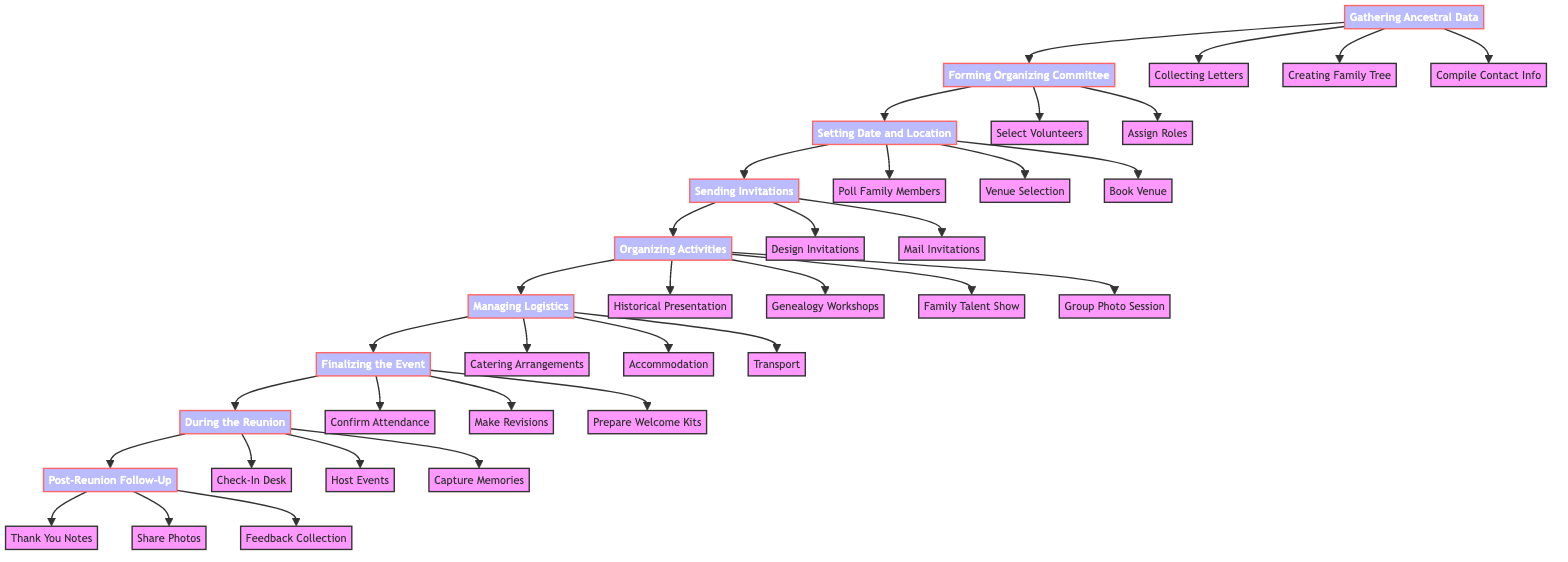What is the first step in organizing the family reunion? The first step in the diagram is "Gathering Ancestral Data". This is depicted as the starting node, from which all other activities branch out.
Answer: Gathering Ancestral Data How many main phases are in the diagram? The diagram contains eight main phases, which are represented as distinct nodes: Gathering Ancestral Data, Forming Organizing Committee, Setting Date and Location, Sending Invitations, Organizing Activities, Managing Logistics, Finalizing the Event, During the Reunion, and Post-Reunion Follow-Up.
Answer: Eight What follows "Sending Invitations" in the flowchart? "Organizing Activities" follows directly after "Sending Invitations". This is indicated by the arrow that connects these two nodes in the flowchart.
Answer: Organizing Activities Which role is responsible for managing budget and expenses? The Finance Manager is responsible for managing the budget and expenses, as shown under "Assign Roles" within the "Forming Organizing Committee" phase.
Answer: Finance Manager How many activities are listed under "Organizing Activities"? There are four activities listed under "Organizing Activities": Historical Presentation, Genealogy Workshops, Family Talent Show, and Group Photo Session, as shown in the flowchart.
Answer: Four What is the final phase in the diagram? The final phase in the diagram is "Post-Reunion Follow-Up", which is the last node that does not lead to any additional nodes, indicating the end of the flow.
Answer: Post-Reunion Follow-Up Which part of the process involves polling family members? "Setting Date and Location" involves polling family members, specifically the step labeled "Poll Family Members". This step aims to find a date that works for most attendees.
Answer: Poll Family Members What should be prepared according to the finalizing phase? "Prepare Welcome Kits" is the specific task that should be completed in the "Finalizing the Event" phase, which involves creating kits for attendees.
Answer: Prepare Welcome Kits Who is responsible for overseeing event logistics? The Event Planner is responsible for overseeing event logistics, as outlined in the roles assigned under the "Forming Organizing Committee" phase of the diagram.
Answer: Event Planner 